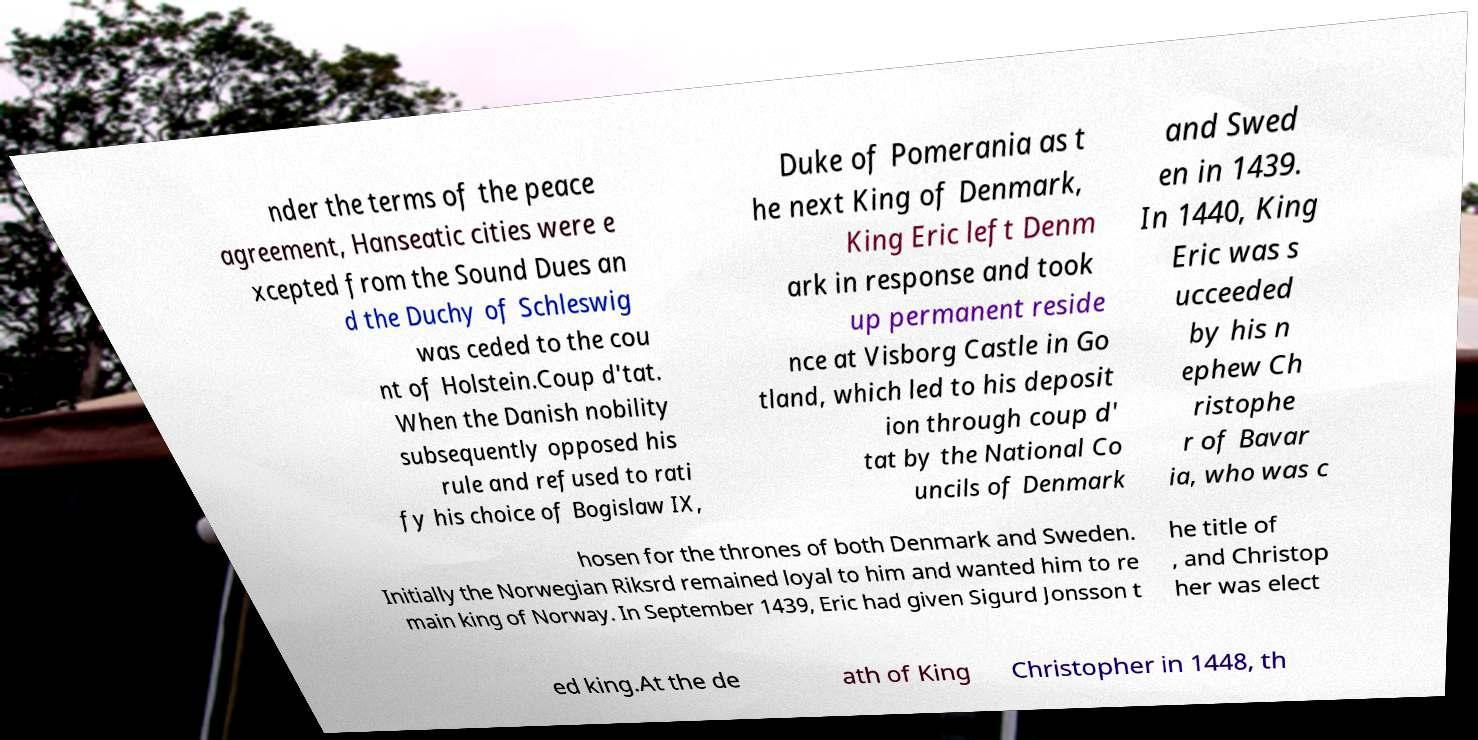What messages or text are displayed in this image? I need them in a readable, typed format. nder the terms of the peace agreement, Hanseatic cities were e xcepted from the Sound Dues an d the Duchy of Schleswig was ceded to the cou nt of Holstein.Coup d'tat. When the Danish nobility subsequently opposed his rule and refused to rati fy his choice of Bogislaw IX, Duke of Pomerania as t he next King of Denmark, King Eric left Denm ark in response and took up permanent reside nce at Visborg Castle in Go tland, which led to his deposit ion through coup d' tat by the National Co uncils of Denmark and Swed en in 1439. In 1440, King Eric was s ucceeded by his n ephew Ch ristophe r of Bavar ia, who was c hosen for the thrones of both Denmark and Sweden. Initially the Norwegian Riksrd remained loyal to him and wanted him to re main king of Norway. In September 1439, Eric had given Sigurd Jonsson t he title of , and Christop her was elect ed king.At the de ath of King Christopher in 1448, th 